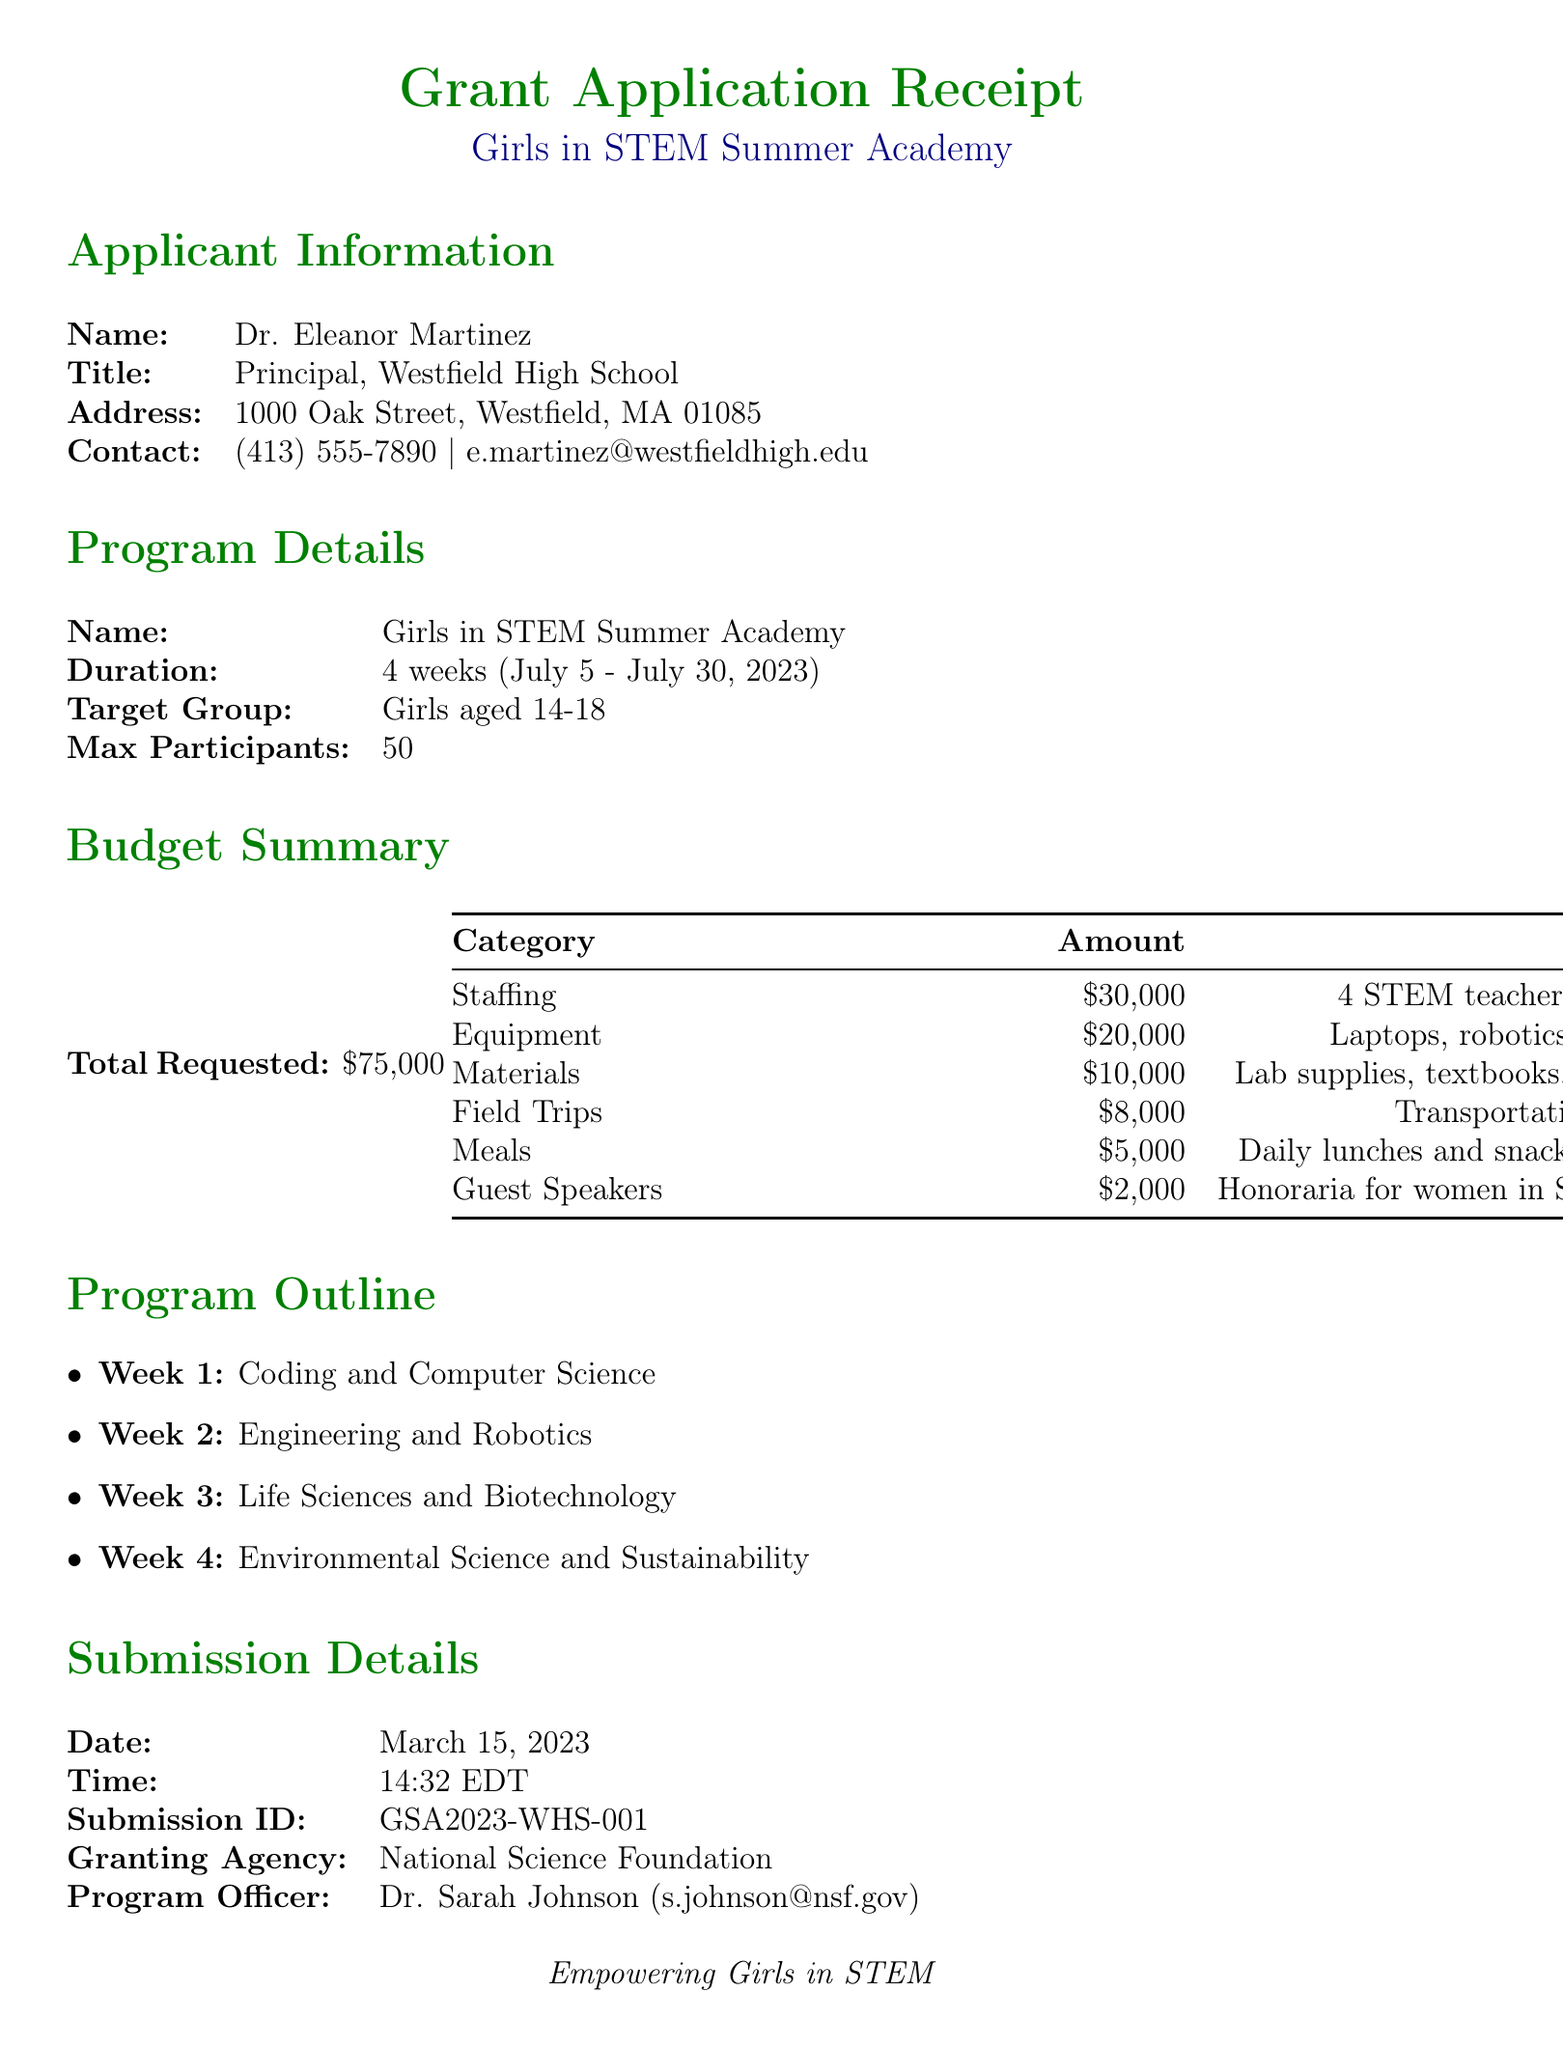What is the name of the program? The program is specifically named "Girls in STEM Summer Academy" in the document.
Answer: Girls in STEM Summer Academy What is the targeted age group for participants? The targeted age group for the program is stated clearly in the document as ages 14-18.
Answer: Girls aged 14-18 How much funding is requested in total? The total amount requested for the grant application is specified in the budget summary section.
Answer: $75,000 What is one of the activities planned for Week 2? The program outline lists activities for each week, including specific activities for Week 2 which focuses on Engineering and Robotics.
Answer: Building and programming Arduino-based robots Who is the program officer for this application? The document identifies the program officer responsible for this grant application.
Answer: Dr. Sarah Johnson What is the budget allocation for Equipment? The budget breakdown details the amount allocated for each category, including Equipment.
Answer: $20,000 When was the application submitted? The submission details section specifies the exact date the grant application was submitted.
Answer: March 15, 2023 What item is funded under Guest Speakers? The budget breakdown provides a description of what the Guest Speakers category includes.
Answer: Honoraria for women in STEM professions 